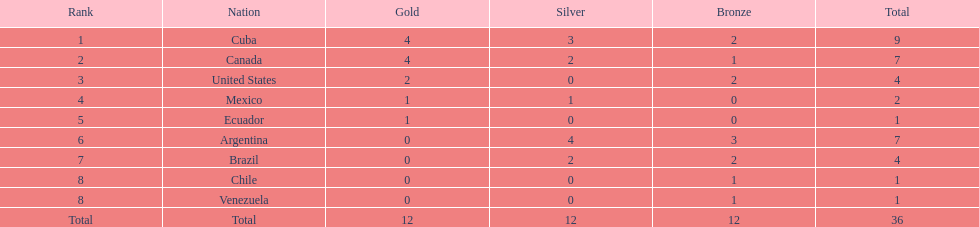Which country won the largest haul of bronze medals? Argentina. 